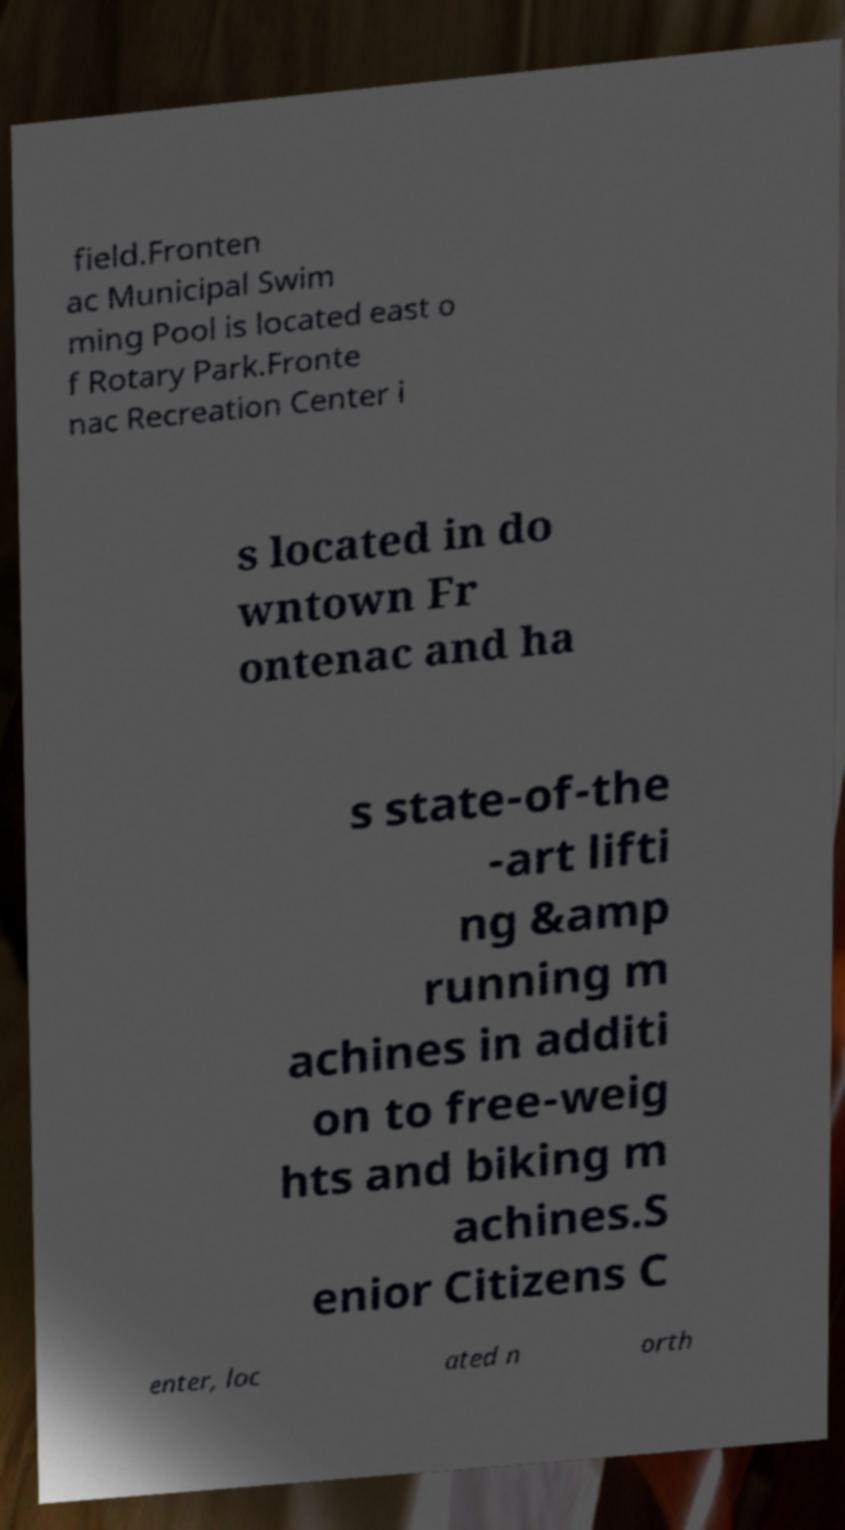Please read and relay the text visible in this image. What does it say? field.Fronten ac Municipal Swim ming Pool is located east o f Rotary Park.Fronte nac Recreation Center i s located in do wntown Fr ontenac and ha s state-of-the -art lifti ng &amp running m achines in additi on to free-weig hts and biking m achines.S enior Citizens C enter, loc ated n orth 